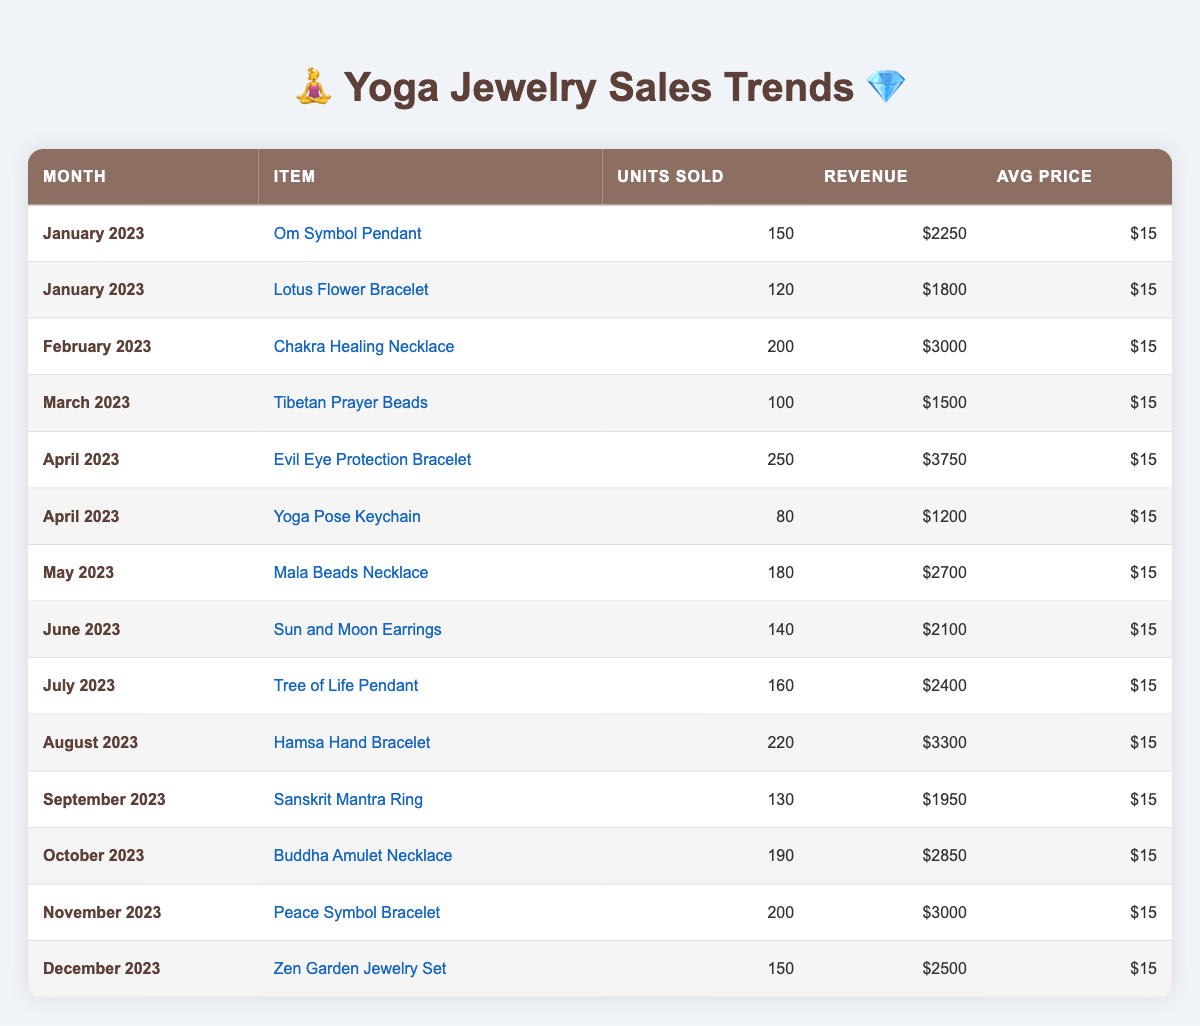What was the month with the highest number of units sold? By reviewing the "Units Sold" column, I can see the maximum value is 250, which corresponds to "Evil Eye Protection Bracelet" in April 2023. Therefore, April 2023 is the month with the highest number of units sold.
Answer: April 2023 What is the total revenue generated from the "Mala Beads Necklace"? The revenue for "Mala Beads Necklace" in May 2023 is given as 2700. Since there is only one entry for this item, the total revenue is simply 2700.
Answer: 2700 How many units of yoga-related jewelry were sold in total from January to December? To find the total units sold, add the values from the "Units Sold" column for all entries: 150 + 120 + 200 + 100 + 250 + 80 + 180 + 140 + 160 + 220 + 130 + 190 + 200 + 150 = 2180.
Answer: 2180 Did sales of the "Hamsa Hand Bracelet" exceed 200 units sold? The "Hamsa Hand Bracelet" sold 220 units in August 2023, which is greater than 200. Therefore, the statement is true.
Answer: Yes What was the average monthly revenue generated from all items sold? First, sum the revenue from all entries: 2250 + 1800 + 3000 + 1500 + 3750 + 1200 + 2700 + 2100 + 2400 + 3300 + 1950 + 2850 + 3000 + 2500 = 26300. Since there are 13 data points (months), the average revenue is 26300 / 13 = 2023.08.
Answer: 2023.08 Which item had the highest average price, and what was that price? Consulting the "Avg Price" column shows every item has an average price of 15. Therefore, all items have the same price, and the highest average price is 15.
Answer: 15 How many more units of the "Evil Eye Protection Bracelet" were sold than the "Yoga Pose Keychain"? The "Evil Eye Protection Bracelet" sold 250 units while the "Yoga Pose Keychain" sold 80 units. Therefore, 250 - 80 = 170 units more were sold.
Answer: 170 In which month did the "Sanskrit Mantra Ring" have the least revenue? The "Sanskrit Mantra Ring," sold in September 2023 for a revenue of 1950. Since it's the only entry for that item, it is also the month with the least revenue for it.
Answer: September 2023 If I consider the last quarter (October to December), what would be the total units sold? For the last quarter, the total units sold are: October (190) + November (200) + December (150) = 540.
Answer: 540 